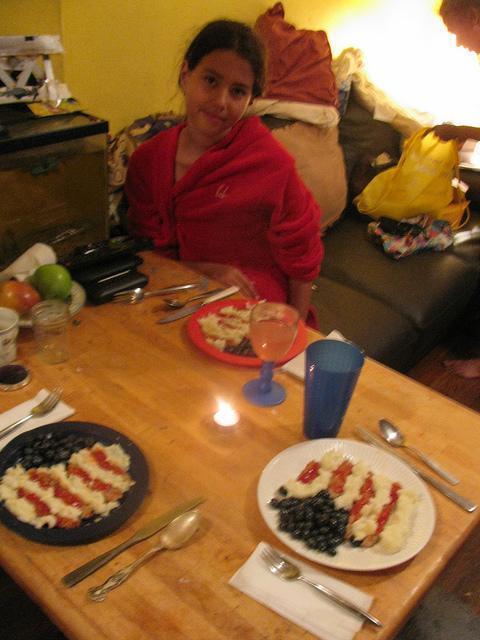How many people are sitting at the table?
Give a very brief answer. 1. How many cups are there?
Give a very brief answer. 2. How many dining tables are there?
Give a very brief answer. 1. How many bottles are there?
Give a very brief answer. 0. 